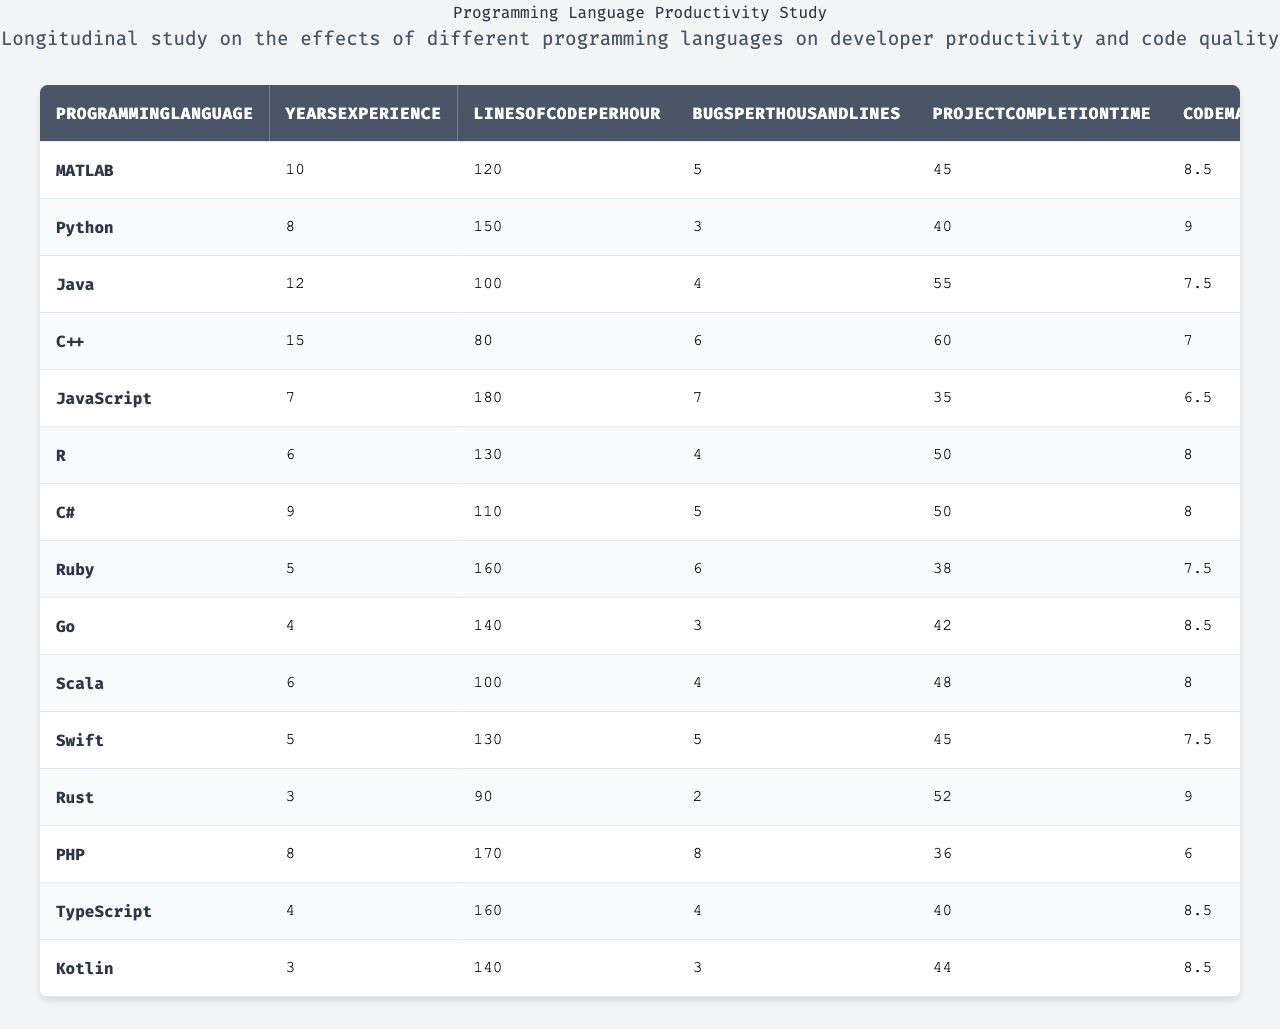Which programming language has the highest lines of code per hour? By inspecting the "LinesOfCodePerHour" column, Python has the highest value at 150.
Answer: Python What is the average number of bugs per thousand lines across all programming languages? To find the average, sum all values in the "BugsPerThousandLines" column: (5 + 3 + 4 + 6 + 7 + 4 + 5 + 6 + 3 + 4 + 5 + 2 + 8 + 4 + 3) = 64. Divide by the total number of languages (15): 64/15 ≈ 4.27.
Answer: Approximately 4.27 Which programming language has the lowest developer satisfaction rating? Looking at the "DeveloperSatisfaction" column, Rust has the lowest score of 7.5.
Answer: Rust Is the execution speed of MATLAB greater than that of Rust? MATLAB has an execution speed of 85, while Rust has 94. Thus, MATLAB's execution speed is less than Rust's.
Answer: No What is the difference in project completion time between the fastest and the slowest programming languages? The fastest project completion time is 35 (JavaScript) and the slowest is 60 (C++). The difference is 60 - 35 = 25.
Answer: 25 Which language has the best score in code maintainability, and what is that score? Reviewing the "CodeMaintainability" column, Python has the highest score at 9.0.
Answer: Python, 9.0 Which programming languages have a learning curve rating greater than 6? By checking the "LearningCurve" column, we see that MATLAB (6), Python (4), C++ (8), JavaScript (5), R (5.5), C# (6.5), Ruby (4.5), Go (6), Scala (7.5), Swift (6), and Kotlin (5.5) all have learning curves greater than 6.
Answer: C++, C#, Scala, Swift What is the total memory usage for all programming languages listed in the table? The total memory usage can be calculated by adding each value in the "MemoryUsage" column: (350 + 280 + 400 + 200 + 320 + 310 + 380 + 300 + 250 + 330 + 290 + 220 + 340 + 300 + 270) = 4310.
Answer: 4310 What percentage of programming languages have a code maintainability score of 8 or higher? There are 6 programming languages with scores of 8 or higher (Python, MATLAB, Go, C#, Kotlin, Rust) out of 15. The percentage is (6/15) * 100 = 40%.
Answer: 40% Is it true that all programming languages have a lines of code per hour rating above 70? Inspecting the "LinesOfCodePerHour" column, C++ has a score of 80, which is below 70, therefore, the statement is false.
Answer: No 